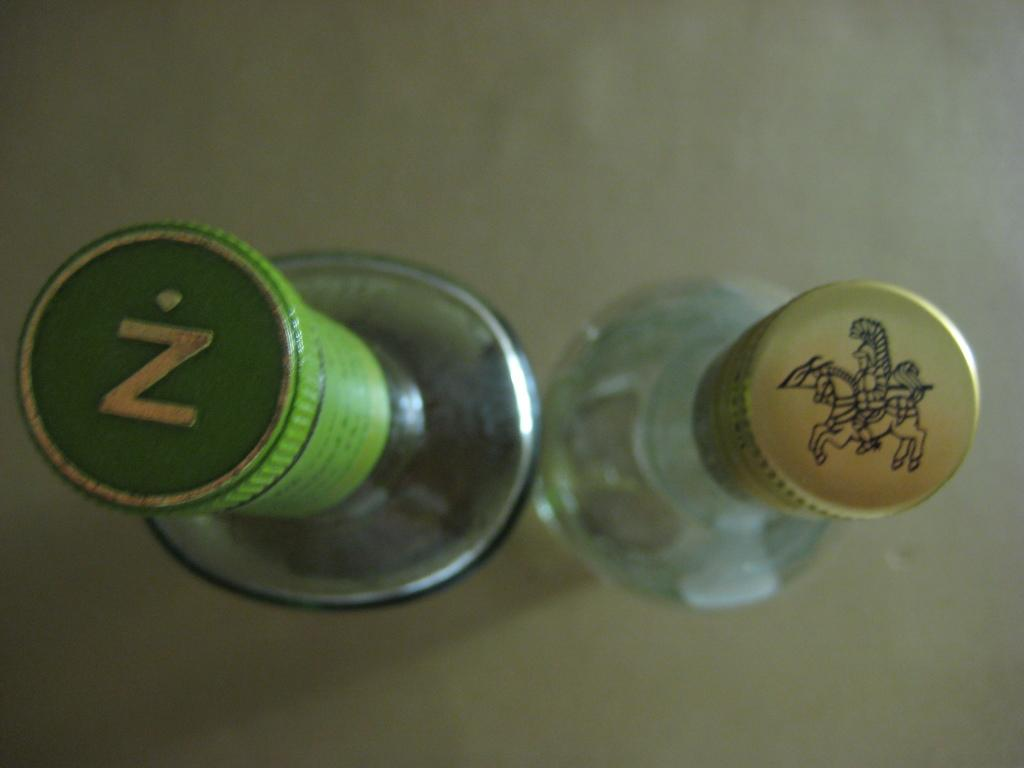What objects can be seen in the image? There are a couple of bottles in the image. Can you describe the bottles in the image? Unfortunately, the provided facts do not give any details about the bottles, such as their size, color, or contents. What might the bottles be used for? The bottles could be used for storing or transporting liquids, but without more information, it is impossible to determine their specific purpose. What type of cake is being served with a spoon in the image? There is no cake or spoon present in the image; it only features a couple of bottles. 